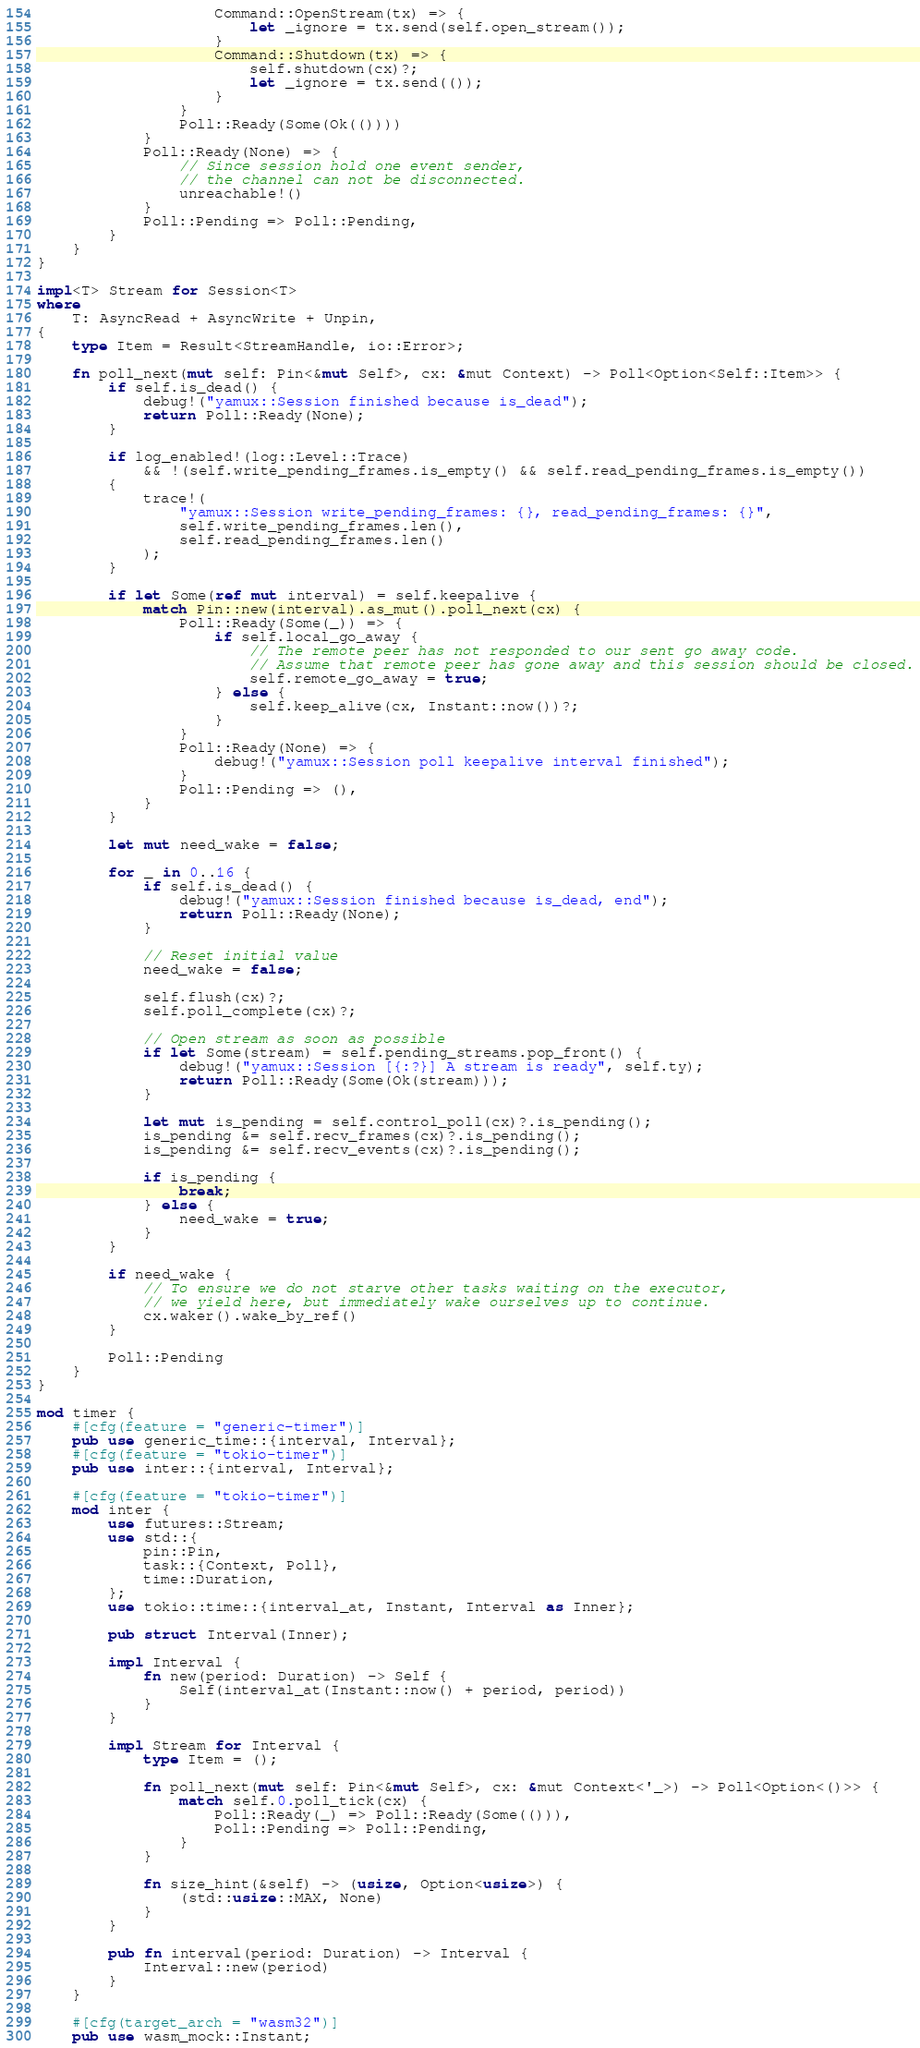Convert code to text. <code><loc_0><loc_0><loc_500><loc_500><_Rust_>                    Command::OpenStream(tx) => {
                        let _ignore = tx.send(self.open_stream());
                    }
                    Command::Shutdown(tx) => {
                        self.shutdown(cx)?;
                        let _ignore = tx.send(());
                    }
                }
                Poll::Ready(Some(Ok(())))
            }
            Poll::Ready(None) => {
                // Since session hold one event sender,
                // the channel can not be disconnected.
                unreachable!()
            }
            Poll::Pending => Poll::Pending,
        }
    }
}

impl<T> Stream for Session<T>
where
    T: AsyncRead + AsyncWrite + Unpin,
{
    type Item = Result<StreamHandle, io::Error>;

    fn poll_next(mut self: Pin<&mut Self>, cx: &mut Context) -> Poll<Option<Self::Item>> {
        if self.is_dead() {
            debug!("yamux::Session finished because is_dead");
            return Poll::Ready(None);
        }

        if log_enabled!(log::Level::Trace)
            && !(self.write_pending_frames.is_empty() && self.read_pending_frames.is_empty())
        {
            trace!(
                "yamux::Session write_pending_frames: {}, read_pending_frames: {}",
                self.write_pending_frames.len(),
                self.read_pending_frames.len()
            );
        }

        if let Some(ref mut interval) = self.keepalive {
            match Pin::new(interval).as_mut().poll_next(cx) {
                Poll::Ready(Some(_)) => {
                    if self.local_go_away {
                        // The remote peer has not responded to our sent go away code.
                        // Assume that remote peer has gone away and this session should be closed.
                        self.remote_go_away = true;
                    } else {
                        self.keep_alive(cx, Instant::now())?;
                    }
                }
                Poll::Ready(None) => {
                    debug!("yamux::Session poll keepalive interval finished");
                }
                Poll::Pending => (),
            }
        }

        let mut need_wake = false;

        for _ in 0..16 {
            if self.is_dead() {
                debug!("yamux::Session finished because is_dead, end");
                return Poll::Ready(None);
            }

            // Reset initial value
            need_wake = false;

            self.flush(cx)?;
            self.poll_complete(cx)?;

            // Open stream as soon as possible
            if let Some(stream) = self.pending_streams.pop_front() {
                debug!("yamux::Session [{:?}] A stream is ready", self.ty);
                return Poll::Ready(Some(Ok(stream)));
            }

            let mut is_pending = self.control_poll(cx)?.is_pending();
            is_pending &= self.recv_frames(cx)?.is_pending();
            is_pending &= self.recv_events(cx)?.is_pending();

            if is_pending {
                break;
            } else {
                need_wake = true;
            }
        }

        if need_wake {
            // To ensure we do not starve other tasks waiting on the executor,
            // we yield here, but immediately wake ourselves up to continue.
            cx.waker().wake_by_ref()
        }

        Poll::Pending
    }
}

mod timer {
    #[cfg(feature = "generic-timer")]
    pub use generic_time::{interval, Interval};
    #[cfg(feature = "tokio-timer")]
    pub use inter::{interval, Interval};

    #[cfg(feature = "tokio-timer")]
    mod inter {
        use futures::Stream;
        use std::{
            pin::Pin,
            task::{Context, Poll},
            time::Duration,
        };
        use tokio::time::{interval_at, Instant, Interval as Inner};

        pub struct Interval(Inner);

        impl Interval {
            fn new(period: Duration) -> Self {
                Self(interval_at(Instant::now() + period, period))
            }
        }

        impl Stream for Interval {
            type Item = ();

            fn poll_next(mut self: Pin<&mut Self>, cx: &mut Context<'_>) -> Poll<Option<()>> {
                match self.0.poll_tick(cx) {
                    Poll::Ready(_) => Poll::Ready(Some(())),
                    Poll::Pending => Poll::Pending,
                }
            }

            fn size_hint(&self) -> (usize, Option<usize>) {
                (std::usize::MAX, None)
            }
        }

        pub fn interval(period: Duration) -> Interval {
            Interval::new(period)
        }
    }

    #[cfg(target_arch = "wasm32")]
    pub use wasm_mock::Instant;
</code> 